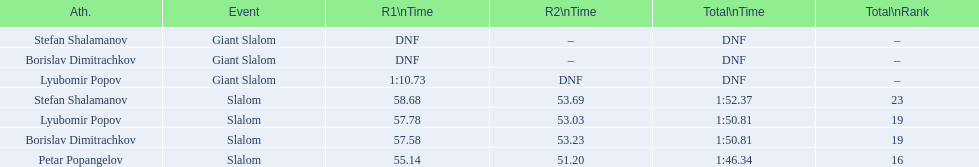How many athletes are there total? 4. 